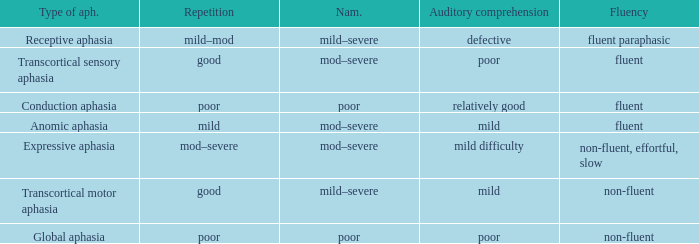Name the number of naming for anomic aphasia 1.0. 